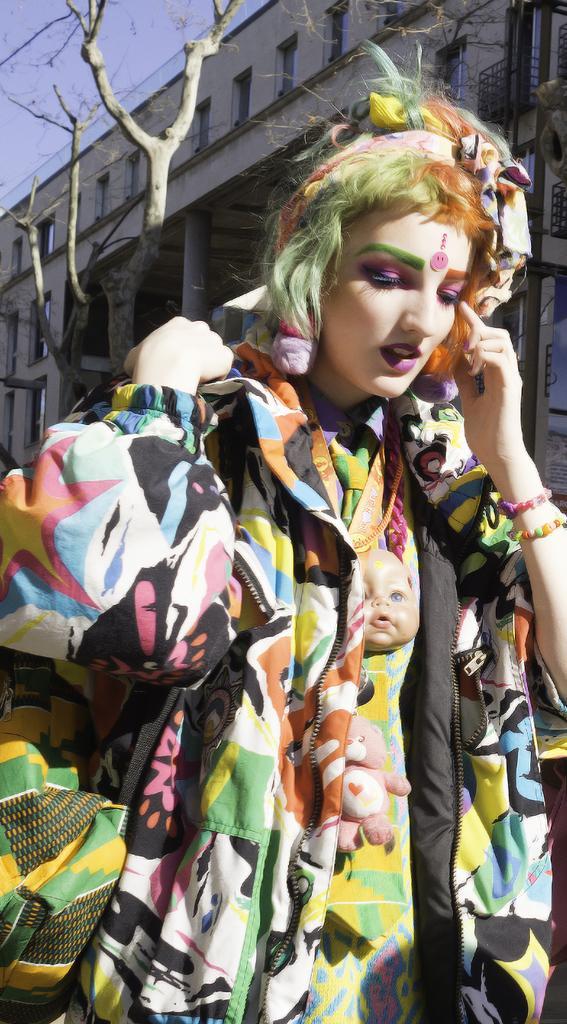Who is the main subject in the image? There is a woman in the image. What is the woman wearing? The woman is wearing a colorful jacket. What can be seen in the background of the image? There is a dry tree and a building in the background of the image. How much profit did the woman make from the tree in the image? There is no mention of profit or any financial transaction in the image, and the tree is dry, so it is not possible to determine any profit made from it. 